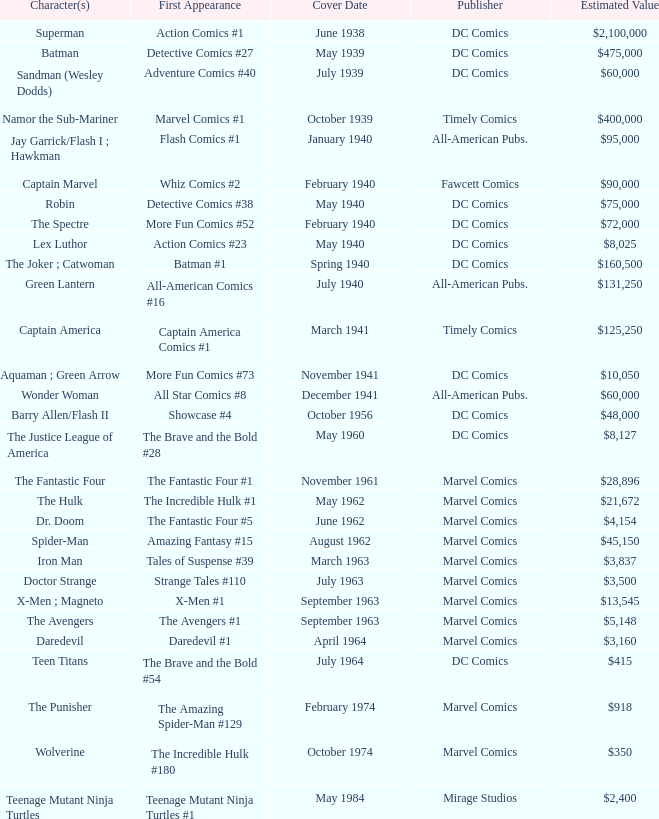Which character first appeared in Amazing Fantasy #15? Spider-Man. 